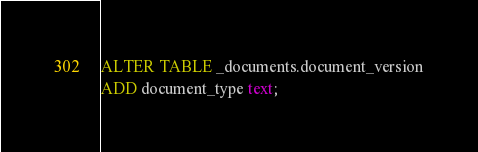Convert code to text. <code><loc_0><loc_0><loc_500><loc_500><_SQL_>
ALTER TABLE _documents.document_version
ADD document_type text; </code> 